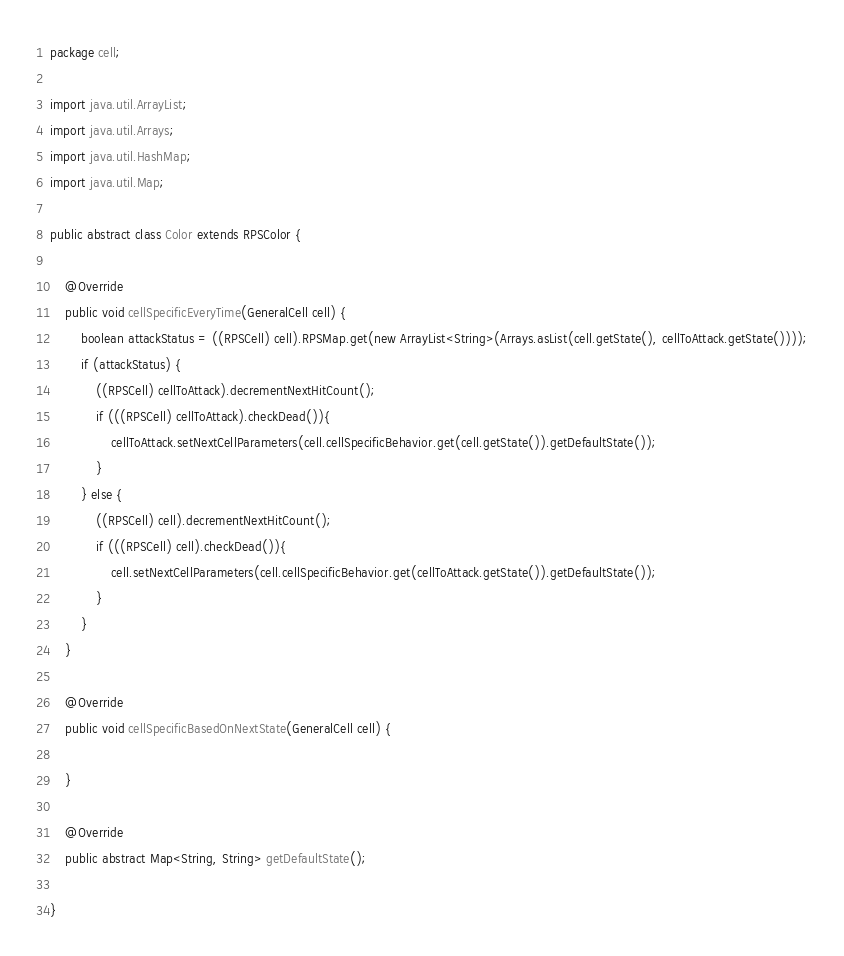Convert code to text. <code><loc_0><loc_0><loc_500><loc_500><_Java_>package cell;

import java.util.ArrayList;
import java.util.Arrays;
import java.util.HashMap;
import java.util.Map;

public abstract class Color extends RPSColor {

	@Override
	public void cellSpecificEveryTime(GeneralCell cell) {
		boolean attackStatus = ((RPSCell) cell).RPSMap.get(new ArrayList<String>(Arrays.asList(cell.getState(), cellToAttack.getState())));
		if (attackStatus) {
			((RPSCell) cellToAttack).decrementNextHitCount();
			if (((RPSCell) cellToAttack).checkDead()){
				cellToAttack.setNextCellParameters(cell.cellSpecificBehavior.get(cell.getState()).getDefaultState());
			}
		} else {
			((RPSCell) cell).decrementNextHitCount();
			if (((RPSCell) cell).checkDead()){
				cell.setNextCellParameters(cell.cellSpecificBehavior.get(cellToAttack.getState()).getDefaultState());
			}
		}
	}

	@Override
	public void cellSpecificBasedOnNextState(GeneralCell cell) {

	}

	@Override
	public abstract Map<String, String> getDefaultState();

}
</code> 